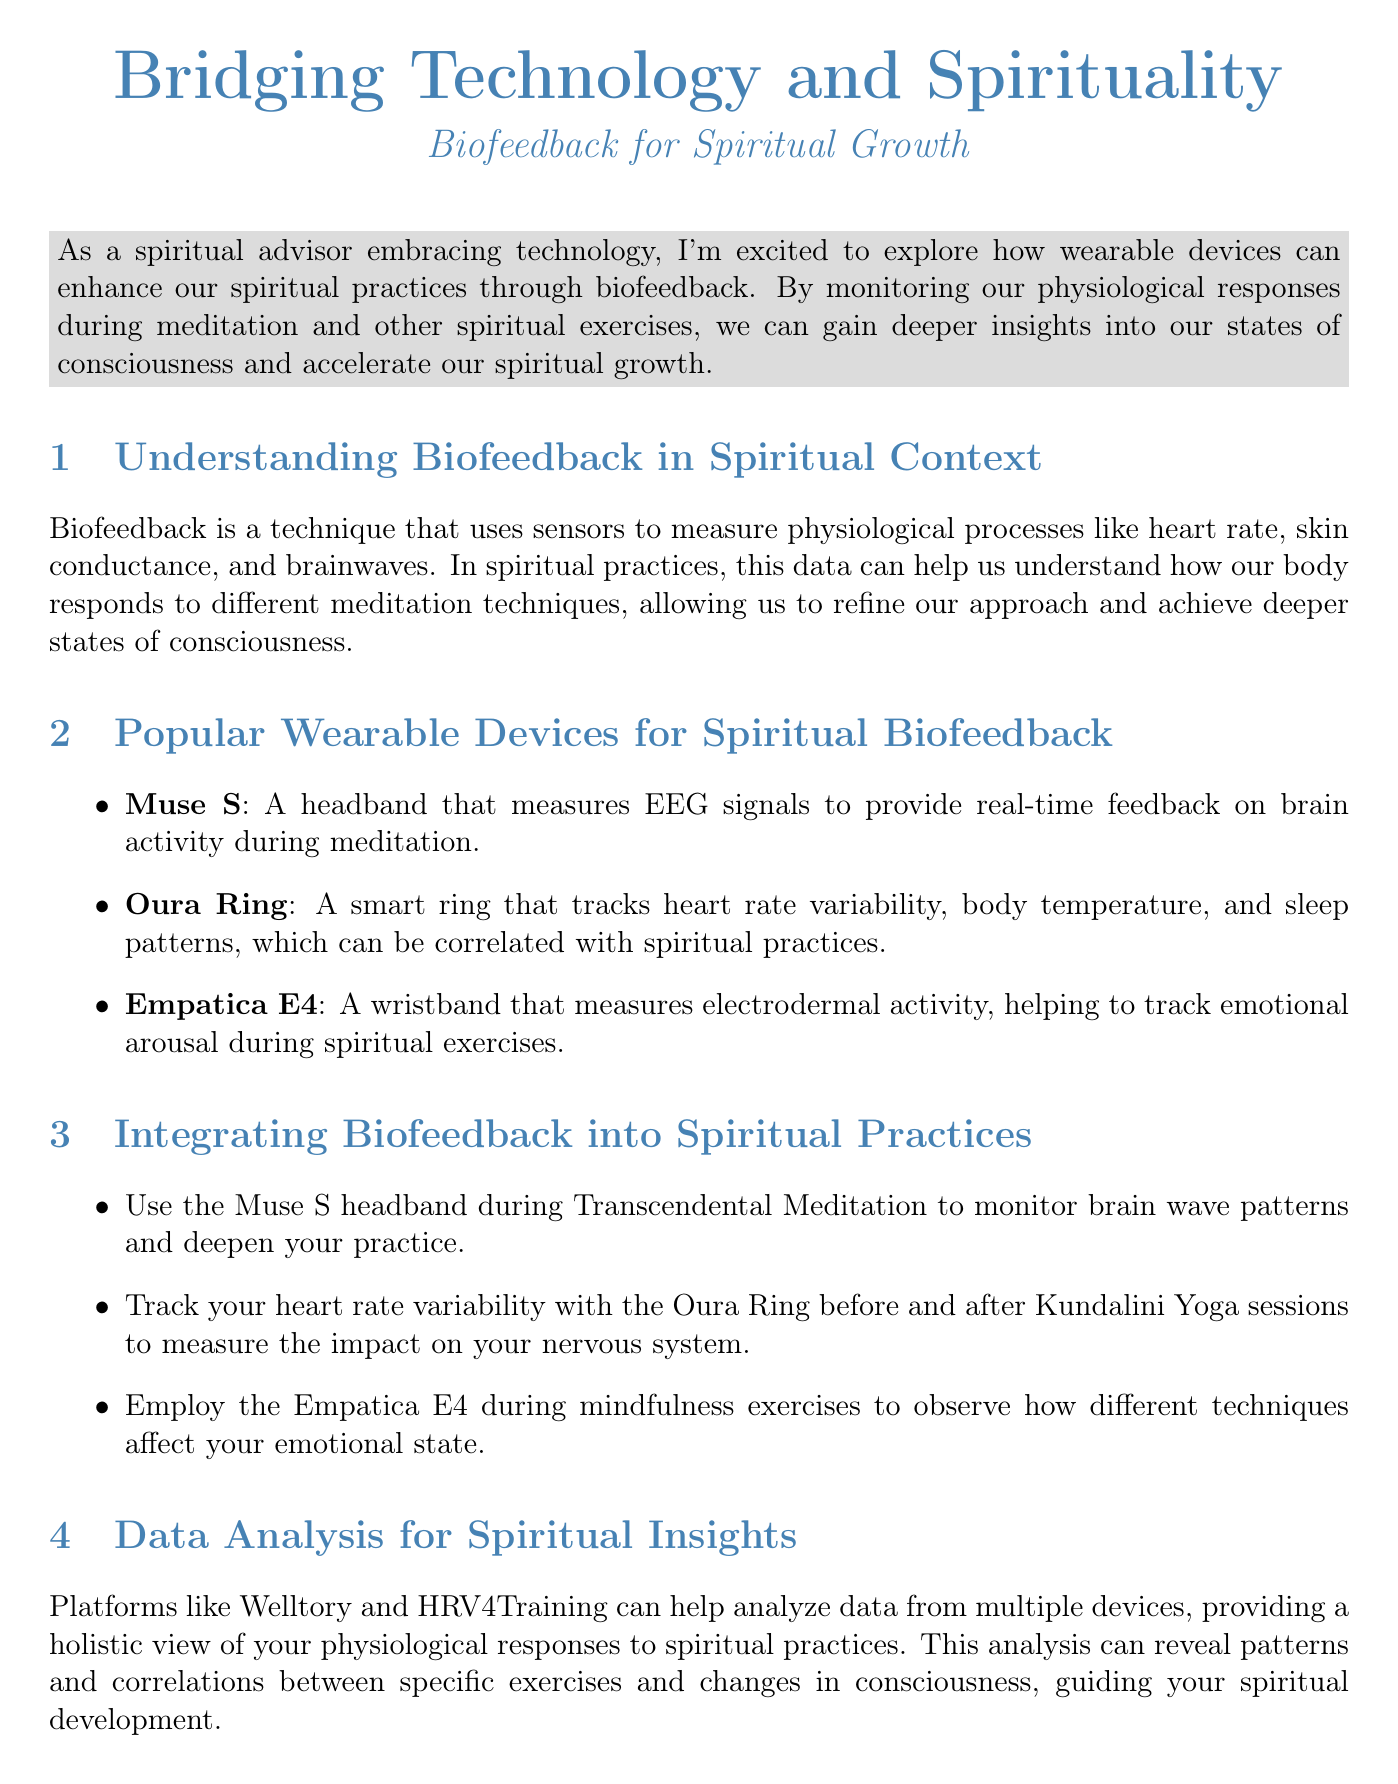What is the title of the newsletter? The title is stated at the beginning of the document.
Answer: Bridging Technology and Spirituality: Biofeedback for Spiritual Growth What is biofeedback? Biofeedback is defined in the section on understanding biofeedback within a spiritual context.
Answer: A technique that uses sensors to measure physiological processes Which wearable device measures EEG signals? The document lists wearable devices along with their descriptions, identifying the one with EEG capabilities.
Answer: Muse S What is the purpose of the Oura Ring? The purpose is mentioned in the context of its tracking abilities as outlined in the newsletter.
Answer: Tracks heart rate variability, body temperature, and sleep patterns What can platforms like Welltory analyze? The analysis capabilities are discussed in the section about data analysis for spiritual insights.
Answer: Data from multiple devices How long was the biofeedback meditation challenge? The length of the personal experience challenge is mentioned within the case study.
Answer: 30 days What is one ethical consideration mentioned? The ethical considerations section lists points regarding the use of biofeedback devices.
Answer: Data privacy and security What type of meditation is suggested with Muse S? The integration section suggests practices for using the device, specifying a particular form of meditation.
Answer: Transcendental Meditation What is the call to action at the end of the newsletter? The call to action gives information about an upcoming workshop provided at the end of the document.
Answer: Join our upcoming online workshop 